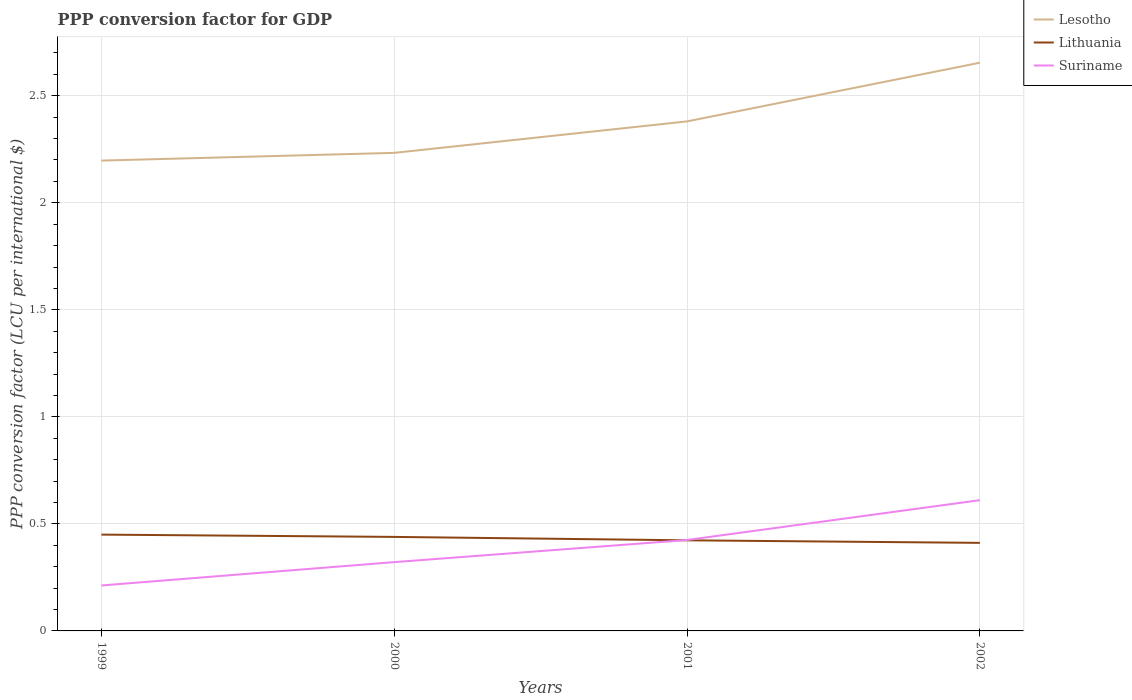Does the line corresponding to Lesotho intersect with the line corresponding to Lithuania?
Provide a succinct answer. No. Across all years, what is the maximum PPP conversion factor for GDP in Suriname?
Provide a succinct answer. 0.21. In which year was the PPP conversion factor for GDP in Lesotho maximum?
Your answer should be compact. 1999. What is the total PPP conversion factor for GDP in Suriname in the graph?
Offer a very short reply. -0.19. What is the difference between the highest and the second highest PPP conversion factor for GDP in Lesotho?
Your answer should be very brief. 0.46. Is the PPP conversion factor for GDP in Suriname strictly greater than the PPP conversion factor for GDP in Lithuania over the years?
Your answer should be compact. No. Are the values on the major ticks of Y-axis written in scientific E-notation?
Ensure brevity in your answer.  No. Does the graph contain any zero values?
Make the answer very short. No. Where does the legend appear in the graph?
Provide a short and direct response. Top right. How many legend labels are there?
Give a very brief answer. 3. How are the legend labels stacked?
Ensure brevity in your answer.  Vertical. What is the title of the graph?
Your answer should be compact. PPP conversion factor for GDP. Does "Namibia" appear as one of the legend labels in the graph?
Provide a short and direct response. No. What is the label or title of the X-axis?
Your answer should be compact. Years. What is the label or title of the Y-axis?
Make the answer very short. PPP conversion factor (LCU per international $). What is the PPP conversion factor (LCU per international $) of Lesotho in 1999?
Give a very brief answer. 2.2. What is the PPP conversion factor (LCU per international $) of Lithuania in 1999?
Provide a succinct answer. 0.45. What is the PPP conversion factor (LCU per international $) in Suriname in 1999?
Offer a very short reply. 0.21. What is the PPP conversion factor (LCU per international $) in Lesotho in 2000?
Keep it short and to the point. 2.23. What is the PPP conversion factor (LCU per international $) in Lithuania in 2000?
Give a very brief answer. 0.44. What is the PPP conversion factor (LCU per international $) in Suriname in 2000?
Offer a terse response. 0.32. What is the PPP conversion factor (LCU per international $) of Lesotho in 2001?
Provide a short and direct response. 2.38. What is the PPP conversion factor (LCU per international $) in Lithuania in 2001?
Offer a terse response. 0.42. What is the PPP conversion factor (LCU per international $) in Suriname in 2001?
Your response must be concise. 0.42. What is the PPP conversion factor (LCU per international $) in Lesotho in 2002?
Give a very brief answer. 2.65. What is the PPP conversion factor (LCU per international $) of Lithuania in 2002?
Your answer should be compact. 0.41. What is the PPP conversion factor (LCU per international $) in Suriname in 2002?
Provide a short and direct response. 0.61. Across all years, what is the maximum PPP conversion factor (LCU per international $) of Lesotho?
Give a very brief answer. 2.65. Across all years, what is the maximum PPP conversion factor (LCU per international $) of Lithuania?
Give a very brief answer. 0.45. Across all years, what is the maximum PPP conversion factor (LCU per international $) in Suriname?
Your answer should be compact. 0.61. Across all years, what is the minimum PPP conversion factor (LCU per international $) in Lesotho?
Your response must be concise. 2.2. Across all years, what is the minimum PPP conversion factor (LCU per international $) in Lithuania?
Your response must be concise. 0.41. Across all years, what is the minimum PPP conversion factor (LCU per international $) in Suriname?
Your response must be concise. 0.21. What is the total PPP conversion factor (LCU per international $) of Lesotho in the graph?
Your answer should be very brief. 9.46. What is the total PPP conversion factor (LCU per international $) of Lithuania in the graph?
Ensure brevity in your answer.  1.72. What is the total PPP conversion factor (LCU per international $) in Suriname in the graph?
Ensure brevity in your answer.  1.57. What is the difference between the PPP conversion factor (LCU per international $) in Lesotho in 1999 and that in 2000?
Give a very brief answer. -0.04. What is the difference between the PPP conversion factor (LCU per international $) in Lithuania in 1999 and that in 2000?
Make the answer very short. 0.01. What is the difference between the PPP conversion factor (LCU per international $) of Suriname in 1999 and that in 2000?
Provide a short and direct response. -0.11. What is the difference between the PPP conversion factor (LCU per international $) in Lesotho in 1999 and that in 2001?
Your answer should be compact. -0.18. What is the difference between the PPP conversion factor (LCU per international $) of Lithuania in 1999 and that in 2001?
Offer a very short reply. 0.03. What is the difference between the PPP conversion factor (LCU per international $) in Suriname in 1999 and that in 2001?
Your answer should be compact. -0.21. What is the difference between the PPP conversion factor (LCU per international $) in Lesotho in 1999 and that in 2002?
Keep it short and to the point. -0.46. What is the difference between the PPP conversion factor (LCU per international $) in Lithuania in 1999 and that in 2002?
Keep it short and to the point. 0.04. What is the difference between the PPP conversion factor (LCU per international $) of Suriname in 1999 and that in 2002?
Offer a terse response. -0.4. What is the difference between the PPP conversion factor (LCU per international $) in Lesotho in 2000 and that in 2001?
Offer a terse response. -0.15. What is the difference between the PPP conversion factor (LCU per international $) of Lithuania in 2000 and that in 2001?
Offer a very short reply. 0.02. What is the difference between the PPP conversion factor (LCU per international $) of Suriname in 2000 and that in 2001?
Your response must be concise. -0.1. What is the difference between the PPP conversion factor (LCU per international $) of Lesotho in 2000 and that in 2002?
Provide a short and direct response. -0.42. What is the difference between the PPP conversion factor (LCU per international $) of Lithuania in 2000 and that in 2002?
Keep it short and to the point. 0.03. What is the difference between the PPP conversion factor (LCU per international $) in Suriname in 2000 and that in 2002?
Provide a succinct answer. -0.29. What is the difference between the PPP conversion factor (LCU per international $) of Lesotho in 2001 and that in 2002?
Give a very brief answer. -0.27. What is the difference between the PPP conversion factor (LCU per international $) in Lithuania in 2001 and that in 2002?
Give a very brief answer. 0.01. What is the difference between the PPP conversion factor (LCU per international $) of Suriname in 2001 and that in 2002?
Offer a very short reply. -0.19. What is the difference between the PPP conversion factor (LCU per international $) of Lesotho in 1999 and the PPP conversion factor (LCU per international $) of Lithuania in 2000?
Provide a succinct answer. 1.76. What is the difference between the PPP conversion factor (LCU per international $) of Lesotho in 1999 and the PPP conversion factor (LCU per international $) of Suriname in 2000?
Make the answer very short. 1.88. What is the difference between the PPP conversion factor (LCU per international $) of Lithuania in 1999 and the PPP conversion factor (LCU per international $) of Suriname in 2000?
Keep it short and to the point. 0.13. What is the difference between the PPP conversion factor (LCU per international $) in Lesotho in 1999 and the PPP conversion factor (LCU per international $) in Lithuania in 2001?
Your answer should be very brief. 1.77. What is the difference between the PPP conversion factor (LCU per international $) of Lesotho in 1999 and the PPP conversion factor (LCU per international $) of Suriname in 2001?
Provide a succinct answer. 1.77. What is the difference between the PPP conversion factor (LCU per international $) in Lithuania in 1999 and the PPP conversion factor (LCU per international $) in Suriname in 2001?
Keep it short and to the point. 0.03. What is the difference between the PPP conversion factor (LCU per international $) in Lesotho in 1999 and the PPP conversion factor (LCU per international $) in Lithuania in 2002?
Keep it short and to the point. 1.79. What is the difference between the PPP conversion factor (LCU per international $) of Lesotho in 1999 and the PPP conversion factor (LCU per international $) of Suriname in 2002?
Give a very brief answer. 1.59. What is the difference between the PPP conversion factor (LCU per international $) in Lithuania in 1999 and the PPP conversion factor (LCU per international $) in Suriname in 2002?
Offer a terse response. -0.16. What is the difference between the PPP conversion factor (LCU per international $) of Lesotho in 2000 and the PPP conversion factor (LCU per international $) of Lithuania in 2001?
Ensure brevity in your answer.  1.81. What is the difference between the PPP conversion factor (LCU per international $) of Lesotho in 2000 and the PPP conversion factor (LCU per international $) of Suriname in 2001?
Ensure brevity in your answer.  1.81. What is the difference between the PPP conversion factor (LCU per international $) in Lithuania in 2000 and the PPP conversion factor (LCU per international $) in Suriname in 2001?
Your answer should be very brief. 0.01. What is the difference between the PPP conversion factor (LCU per international $) in Lesotho in 2000 and the PPP conversion factor (LCU per international $) in Lithuania in 2002?
Give a very brief answer. 1.82. What is the difference between the PPP conversion factor (LCU per international $) of Lesotho in 2000 and the PPP conversion factor (LCU per international $) of Suriname in 2002?
Ensure brevity in your answer.  1.62. What is the difference between the PPP conversion factor (LCU per international $) of Lithuania in 2000 and the PPP conversion factor (LCU per international $) of Suriname in 2002?
Offer a terse response. -0.17. What is the difference between the PPP conversion factor (LCU per international $) in Lesotho in 2001 and the PPP conversion factor (LCU per international $) in Lithuania in 2002?
Your response must be concise. 1.97. What is the difference between the PPP conversion factor (LCU per international $) of Lesotho in 2001 and the PPP conversion factor (LCU per international $) of Suriname in 2002?
Your answer should be compact. 1.77. What is the difference between the PPP conversion factor (LCU per international $) in Lithuania in 2001 and the PPP conversion factor (LCU per international $) in Suriname in 2002?
Keep it short and to the point. -0.19. What is the average PPP conversion factor (LCU per international $) of Lesotho per year?
Your response must be concise. 2.37. What is the average PPP conversion factor (LCU per international $) of Lithuania per year?
Your answer should be compact. 0.43. What is the average PPP conversion factor (LCU per international $) of Suriname per year?
Your response must be concise. 0.39. In the year 1999, what is the difference between the PPP conversion factor (LCU per international $) of Lesotho and PPP conversion factor (LCU per international $) of Lithuania?
Offer a terse response. 1.75. In the year 1999, what is the difference between the PPP conversion factor (LCU per international $) in Lesotho and PPP conversion factor (LCU per international $) in Suriname?
Make the answer very short. 1.98. In the year 1999, what is the difference between the PPP conversion factor (LCU per international $) in Lithuania and PPP conversion factor (LCU per international $) in Suriname?
Give a very brief answer. 0.24. In the year 2000, what is the difference between the PPP conversion factor (LCU per international $) of Lesotho and PPP conversion factor (LCU per international $) of Lithuania?
Your answer should be very brief. 1.79. In the year 2000, what is the difference between the PPP conversion factor (LCU per international $) in Lesotho and PPP conversion factor (LCU per international $) in Suriname?
Make the answer very short. 1.91. In the year 2000, what is the difference between the PPP conversion factor (LCU per international $) in Lithuania and PPP conversion factor (LCU per international $) in Suriname?
Offer a very short reply. 0.12. In the year 2001, what is the difference between the PPP conversion factor (LCU per international $) of Lesotho and PPP conversion factor (LCU per international $) of Lithuania?
Ensure brevity in your answer.  1.96. In the year 2001, what is the difference between the PPP conversion factor (LCU per international $) of Lesotho and PPP conversion factor (LCU per international $) of Suriname?
Provide a short and direct response. 1.96. In the year 2001, what is the difference between the PPP conversion factor (LCU per international $) in Lithuania and PPP conversion factor (LCU per international $) in Suriname?
Make the answer very short. -0. In the year 2002, what is the difference between the PPP conversion factor (LCU per international $) in Lesotho and PPP conversion factor (LCU per international $) in Lithuania?
Provide a short and direct response. 2.24. In the year 2002, what is the difference between the PPP conversion factor (LCU per international $) in Lesotho and PPP conversion factor (LCU per international $) in Suriname?
Give a very brief answer. 2.04. In the year 2002, what is the difference between the PPP conversion factor (LCU per international $) in Lithuania and PPP conversion factor (LCU per international $) in Suriname?
Your answer should be compact. -0.2. What is the ratio of the PPP conversion factor (LCU per international $) of Lesotho in 1999 to that in 2000?
Provide a succinct answer. 0.98. What is the ratio of the PPP conversion factor (LCU per international $) in Lithuania in 1999 to that in 2000?
Offer a very short reply. 1.02. What is the ratio of the PPP conversion factor (LCU per international $) of Suriname in 1999 to that in 2000?
Ensure brevity in your answer.  0.66. What is the ratio of the PPP conversion factor (LCU per international $) in Lesotho in 1999 to that in 2001?
Your answer should be compact. 0.92. What is the ratio of the PPP conversion factor (LCU per international $) of Lithuania in 1999 to that in 2001?
Offer a very short reply. 1.06. What is the ratio of the PPP conversion factor (LCU per international $) in Lesotho in 1999 to that in 2002?
Provide a short and direct response. 0.83. What is the ratio of the PPP conversion factor (LCU per international $) of Lithuania in 1999 to that in 2002?
Offer a very short reply. 1.09. What is the ratio of the PPP conversion factor (LCU per international $) of Suriname in 1999 to that in 2002?
Ensure brevity in your answer.  0.35. What is the ratio of the PPP conversion factor (LCU per international $) of Lesotho in 2000 to that in 2001?
Make the answer very short. 0.94. What is the ratio of the PPP conversion factor (LCU per international $) in Lithuania in 2000 to that in 2001?
Provide a succinct answer. 1.04. What is the ratio of the PPP conversion factor (LCU per international $) of Suriname in 2000 to that in 2001?
Your response must be concise. 0.76. What is the ratio of the PPP conversion factor (LCU per international $) in Lesotho in 2000 to that in 2002?
Provide a succinct answer. 0.84. What is the ratio of the PPP conversion factor (LCU per international $) in Lithuania in 2000 to that in 2002?
Offer a terse response. 1.07. What is the ratio of the PPP conversion factor (LCU per international $) of Suriname in 2000 to that in 2002?
Offer a terse response. 0.53. What is the ratio of the PPP conversion factor (LCU per international $) in Lesotho in 2001 to that in 2002?
Your answer should be compact. 0.9. What is the ratio of the PPP conversion factor (LCU per international $) of Lithuania in 2001 to that in 2002?
Keep it short and to the point. 1.03. What is the ratio of the PPP conversion factor (LCU per international $) of Suriname in 2001 to that in 2002?
Offer a terse response. 0.7. What is the difference between the highest and the second highest PPP conversion factor (LCU per international $) of Lesotho?
Make the answer very short. 0.27. What is the difference between the highest and the second highest PPP conversion factor (LCU per international $) of Lithuania?
Your answer should be very brief. 0.01. What is the difference between the highest and the second highest PPP conversion factor (LCU per international $) in Suriname?
Make the answer very short. 0.19. What is the difference between the highest and the lowest PPP conversion factor (LCU per international $) of Lesotho?
Ensure brevity in your answer.  0.46. What is the difference between the highest and the lowest PPP conversion factor (LCU per international $) in Lithuania?
Your response must be concise. 0.04. What is the difference between the highest and the lowest PPP conversion factor (LCU per international $) in Suriname?
Offer a terse response. 0.4. 